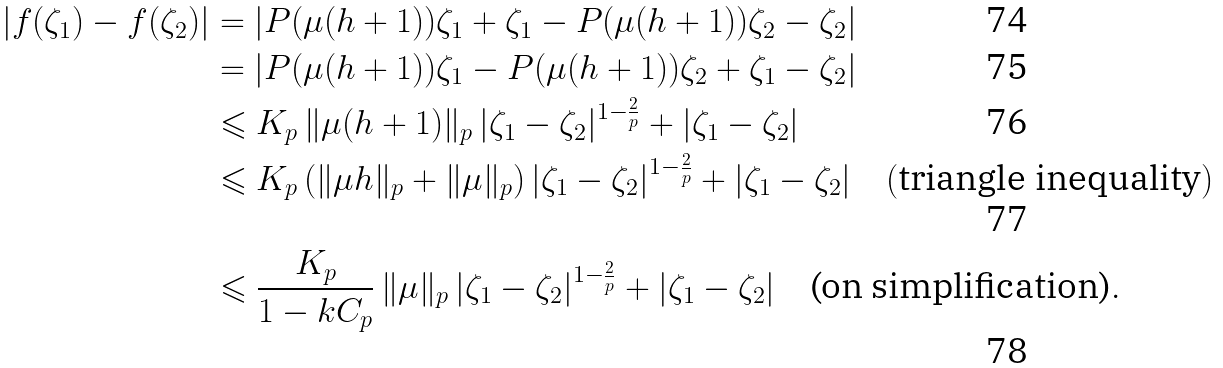Convert formula to latex. <formula><loc_0><loc_0><loc_500><loc_500>| f ( \zeta _ { 1 } ) - f ( \zeta _ { 2 } ) | & = | P ( \mu ( h + 1 ) ) \zeta _ { 1 } + \zeta _ { 1 } - P ( \mu ( h + 1 ) ) \zeta _ { 2 } - \zeta _ { 2 } | \\ & = | P ( \mu ( h + 1 ) ) \zeta _ { 1 } - P ( \mu ( h + 1 ) ) \zeta _ { 2 } + \zeta _ { 1 } - \zeta _ { 2 } | \\ & \leqslant K _ { p } \, \| \mu ( h + 1 ) \| _ { p } \, | \zeta _ { 1 } - \zeta _ { 2 } | ^ { 1 - \frac { 2 } { p } } + | \zeta _ { 1 } - \zeta _ { 2 } | \\ & \leqslant K _ { p } \, ( \| \mu h \| _ { p } + \| \mu \| _ { p } ) \, | \zeta _ { 1 } - \zeta _ { 2 } | ^ { 1 - \frac { 2 } { p } } + | \zeta _ { 1 } - \zeta _ { 2 } | \quad ( \text {triangle inequality} ) \\ & \leqslant \frac { K _ { p } } { 1 - k C _ { p } } \, \| \mu \| _ { p } \, | \zeta _ { 1 } - \zeta _ { 2 } | ^ { 1 - \frac { 2 } { p } } + | \zeta _ { 1 } - \zeta _ { 2 } | \quad \text {(on simplification)} .</formula> 